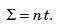Convert formula to latex. <formula><loc_0><loc_0><loc_500><loc_500>\Sigma = n t .</formula> 